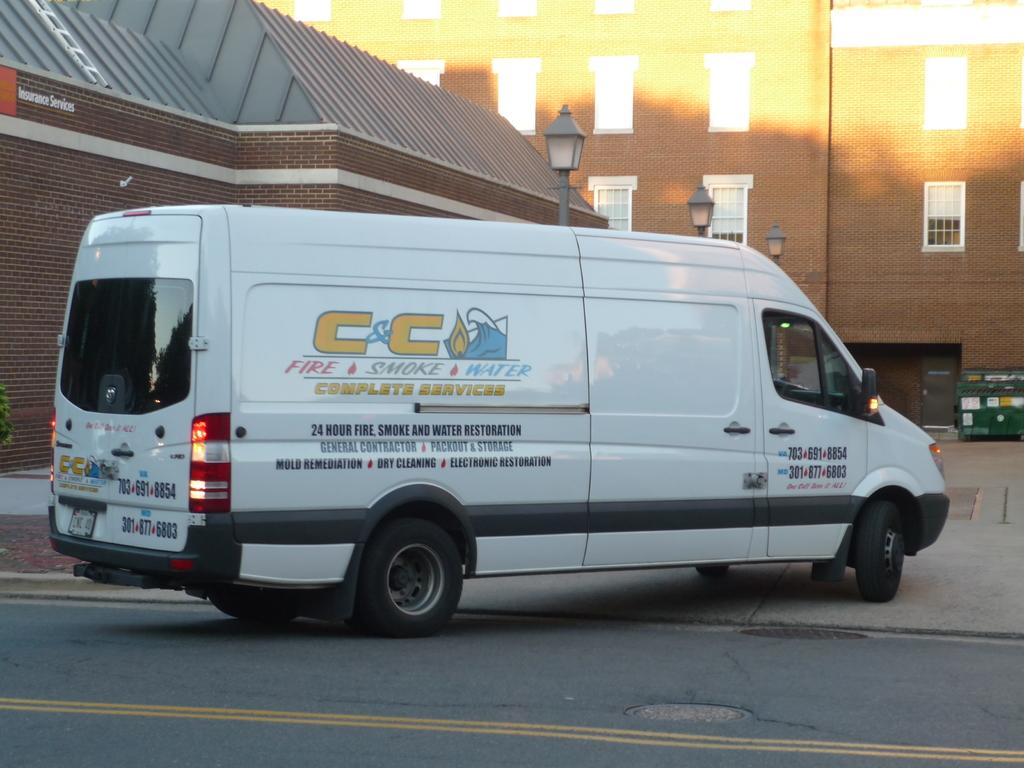How many hours is the company open?
Your response must be concise. 24. What is the name of the company that owns the van?
Give a very brief answer. C&c. 